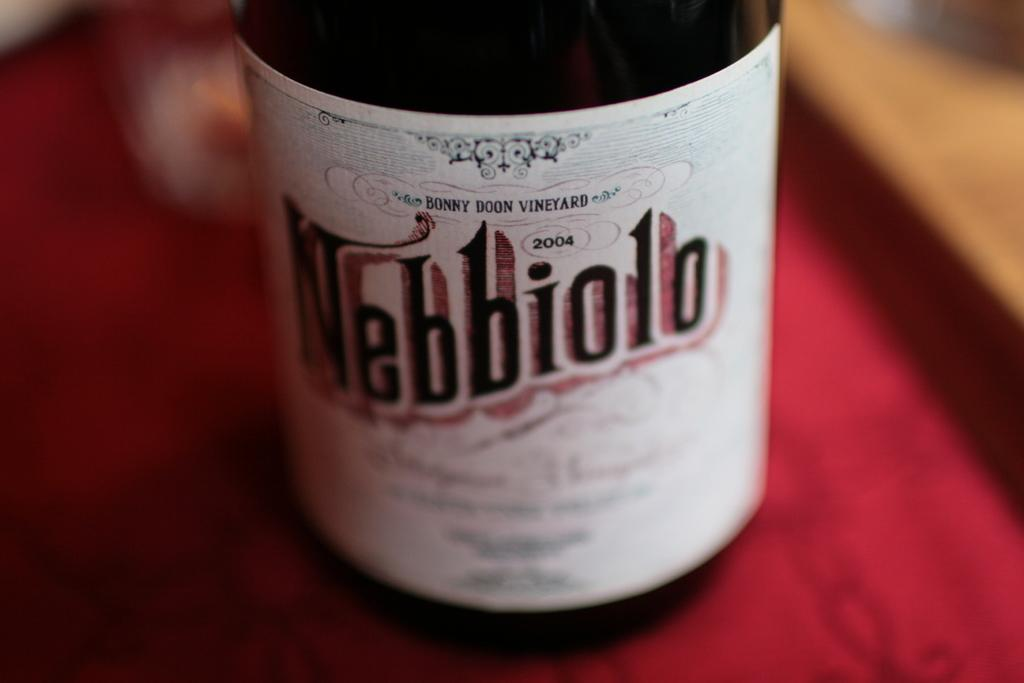Provide a one-sentence caption for the provided image. A bottle of nebbiolo sits on a red cloth. 